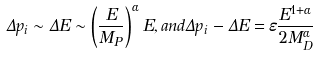<formula> <loc_0><loc_0><loc_500><loc_500>\Delta p _ { i } \sim \Delta E \sim \left ( \frac { E } { M _ { P } } \right ) ^ { \alpha } E , a n d \Delta p _ { i } - \Delta E = \varepsilon \frac { E ^ { 1 + \alpha } } { 2 M _ { D } ^ { \alpha } }</formula> 